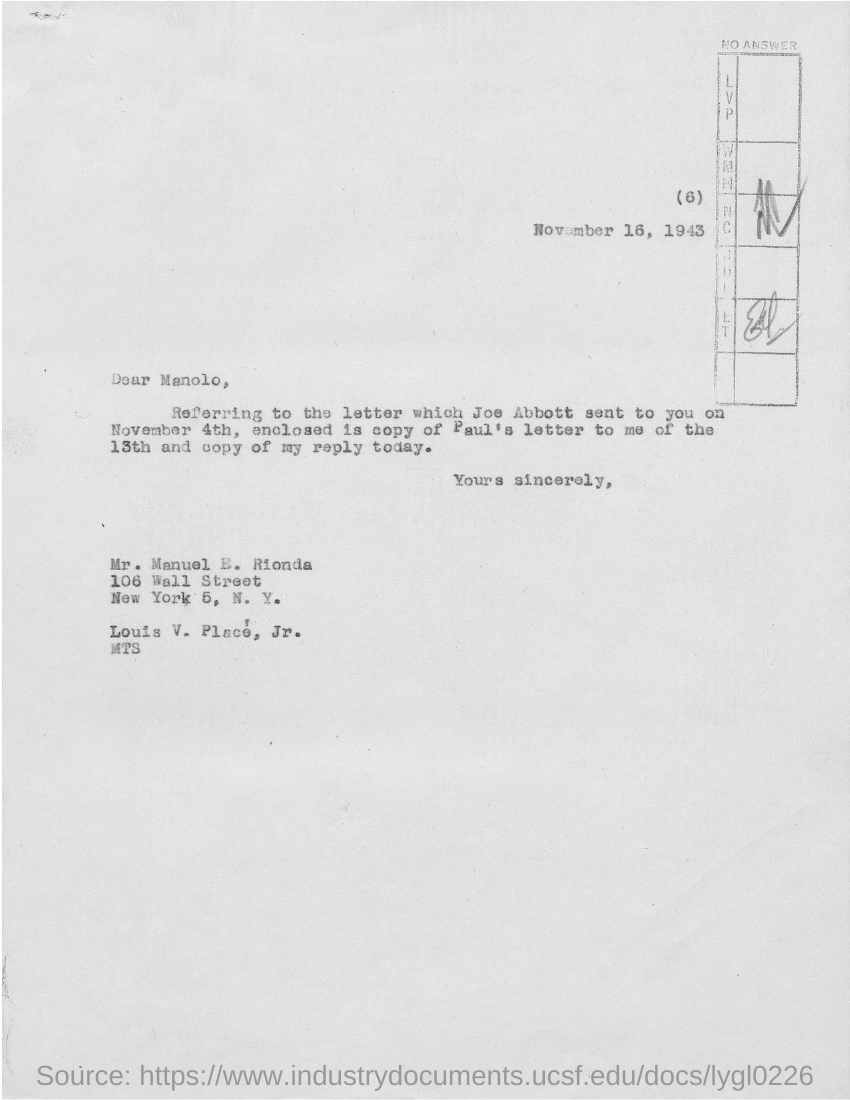When is the letter dated ?
Your answer should be very brief. November 16, 1943. To whom is this letter written to?
Offer a very short reply. Manolo. 